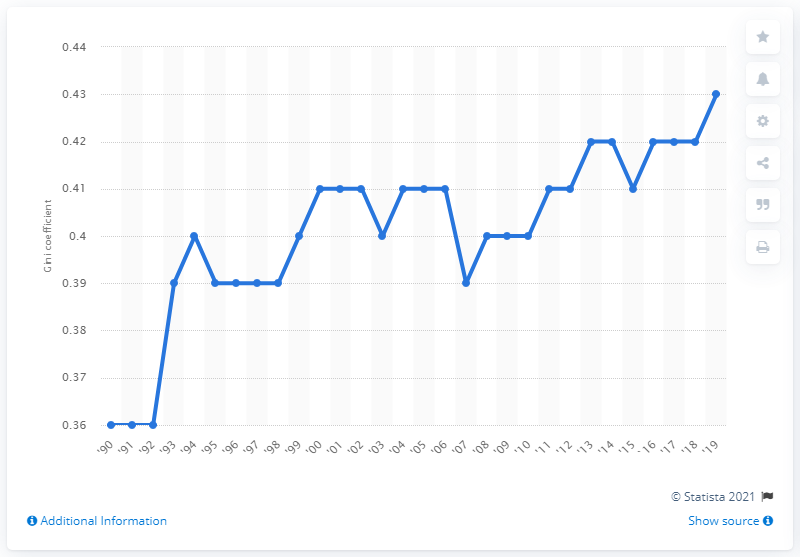Draw attention to some important aspects in this diagram. According to the data, the Gini coefficient for individual income in 2019 was 0.43, which indicates a moderate level of income inequality in the population. 